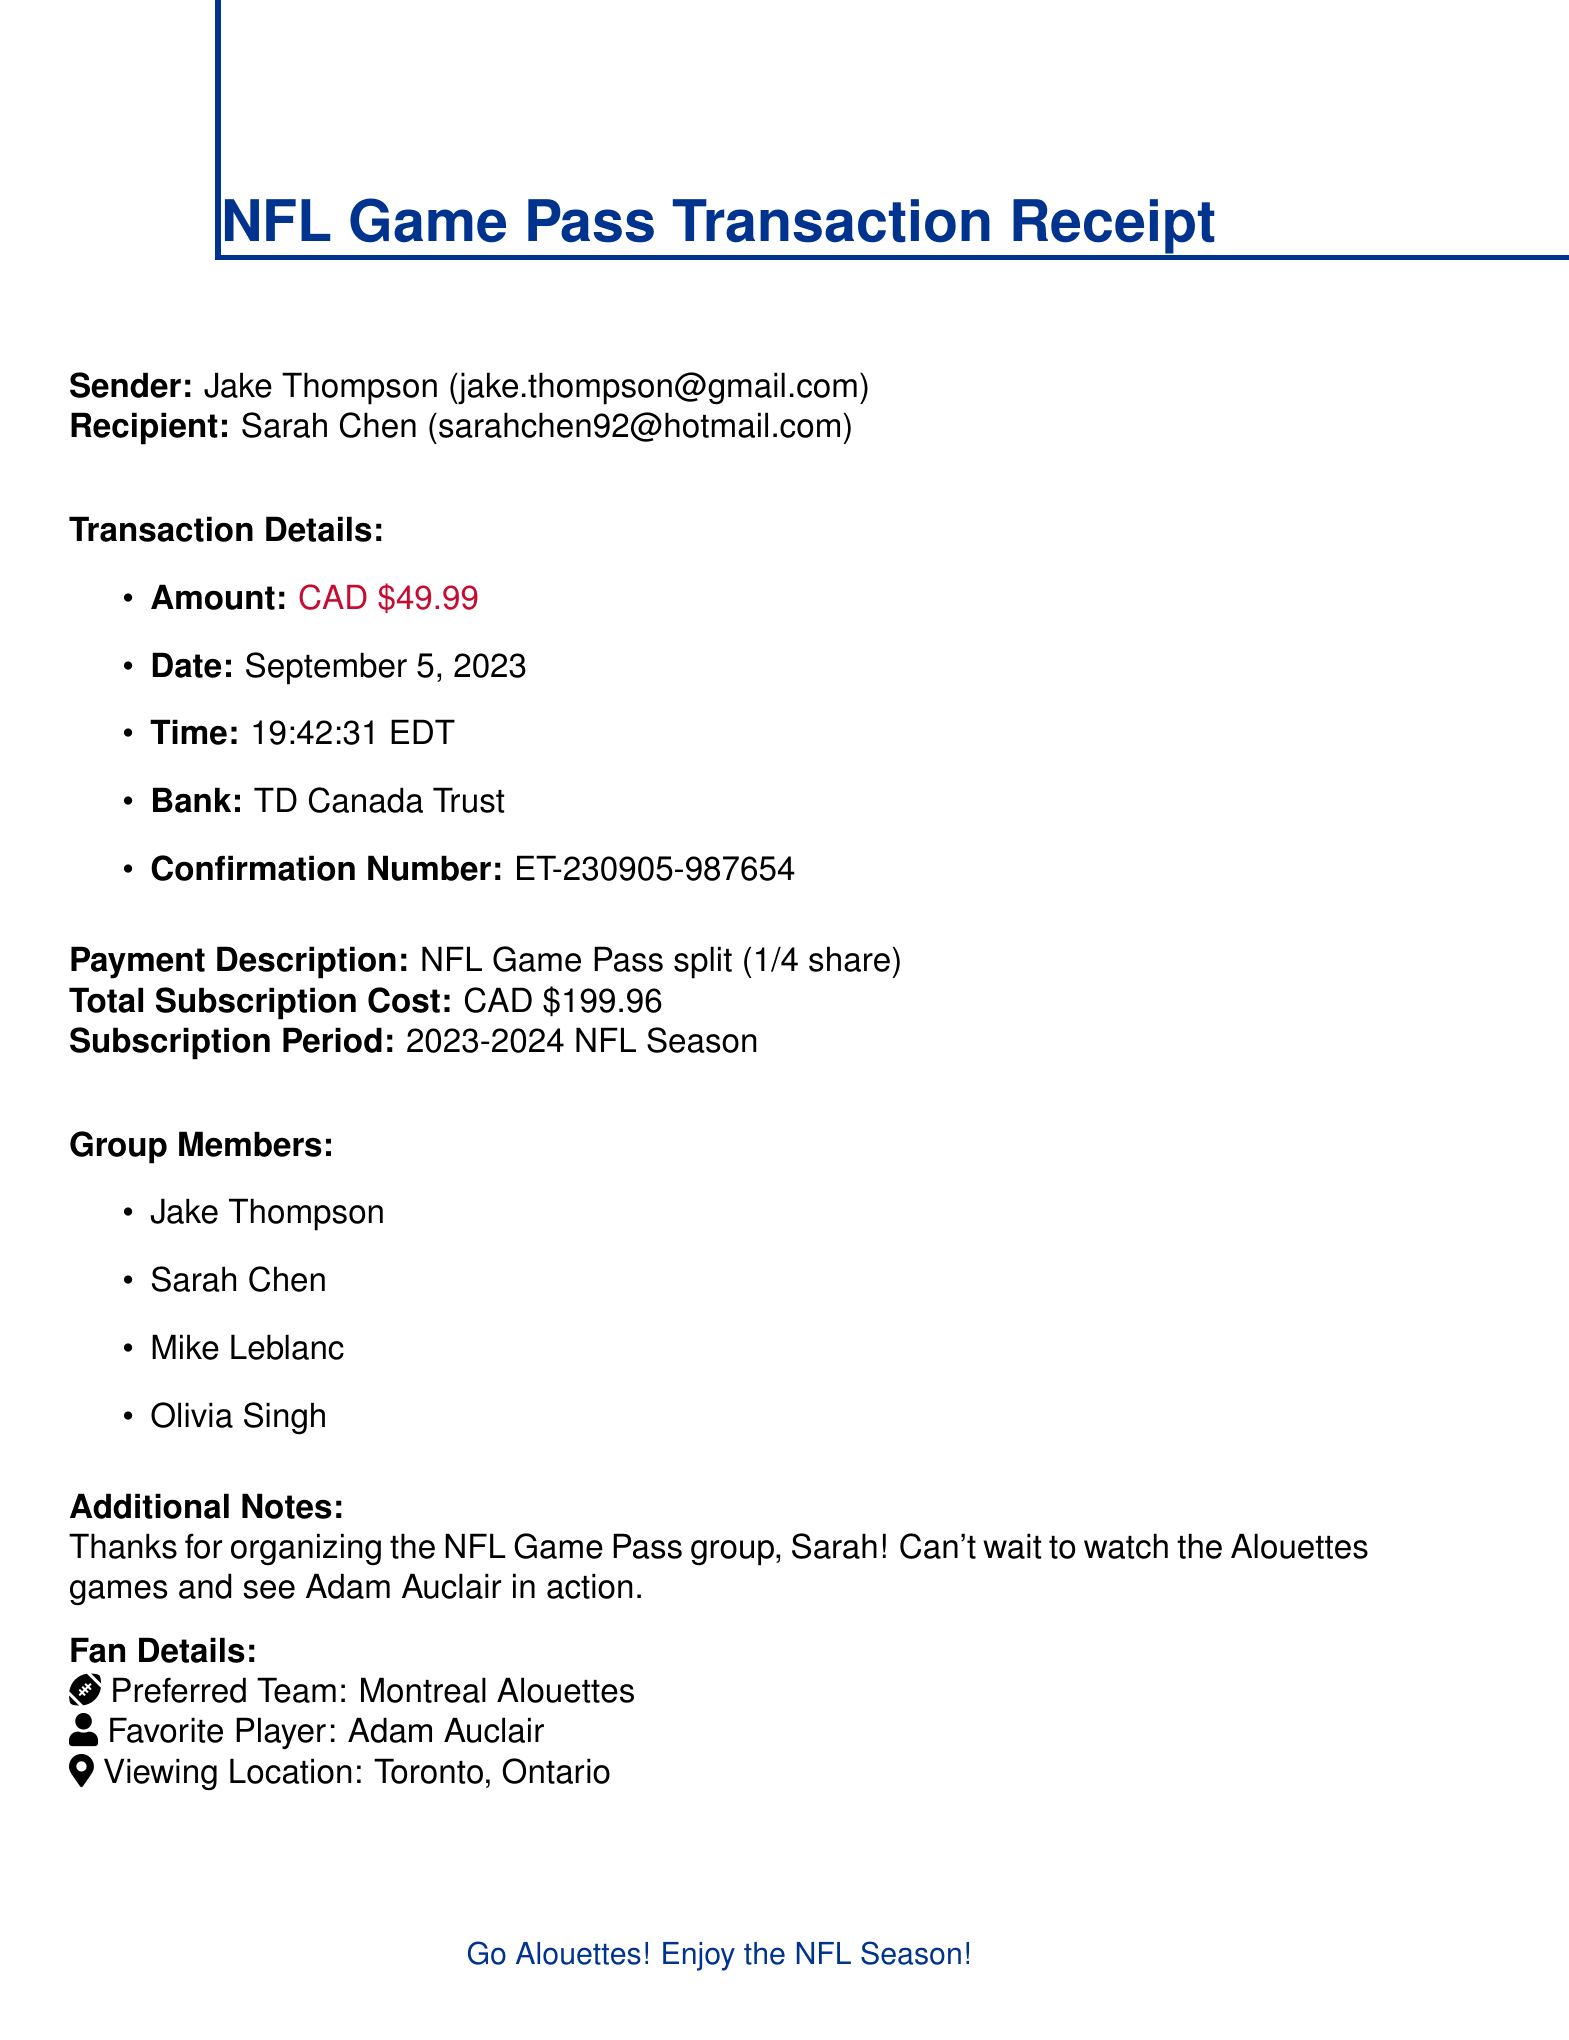what is the sender's name? The sender's name is listed in the document as Jake Thompson.
Answer: Jake Thompson who is the recipient of the e-transfer? The recipient is specified in the document as Sarah Chen.
Answer: Sarah Chen what was the amount of the transaction? The amount of the transaction is shown as CAD 49.99.
Answer: CAD 49.99 when did the transaction take place? The document states the transaction date as September 5, 2023.
Answer: September 5, 2023 what is the confirmation number? The confirmation number is a unique identifier for the transaction found in the document.
Answer: ET-230905-987654 how many members are splitting the Game Pass? The document lists the group members involved in the Game Pass split.
Answer: 4 what is the total subscription cost? The document specifies the total cost for the NFL Game Pass subscription.
Answer: CAD 199.96 which team is the sender's preferred team? The sender's preferred team is mentioned in the fan details section of the document.
Answer: Montreal Alouettes who organized the NFL Game Pass group? The document includes a note thanking the person who organized the group.
Answer: Sarah what is the viewing location for the games? The document includes a specific location where the games will be viewed.
Answer: Toronto, Ontario 